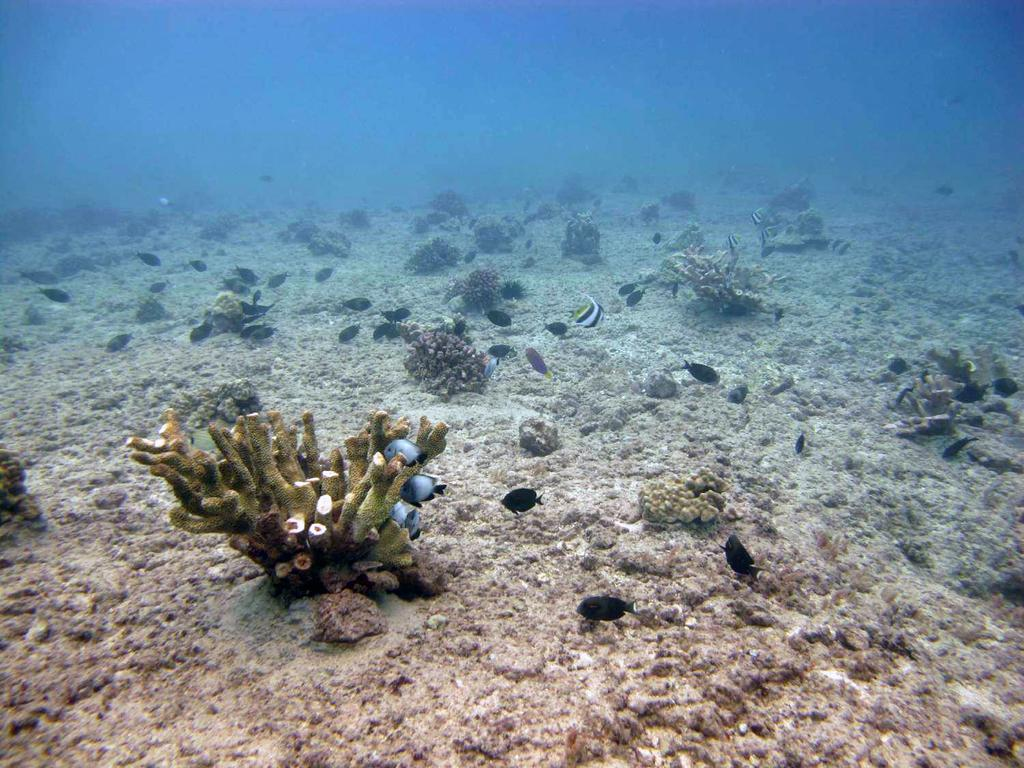What objects are on the ground in the image? There are planets on the ground in the image. What can be seen in the water in the image? There is a group of fish in the water in the image. What type of salt is sprinkled on the planets in the image? There is no salt present in the image; it features planets on the ground and a group of fish in the water. What grade of bear can be seen interacting with the planets in the image? There are no bears present in the image; it only features planets on the ground and a group of fish in the water. 